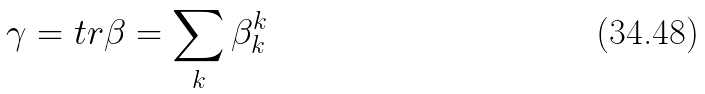<formula> <loc_0><loc_0><loc_500><loc_500>\gamma = t r \beta = \sum _ { k } \beta ^ { k } _ { k }</formula> 